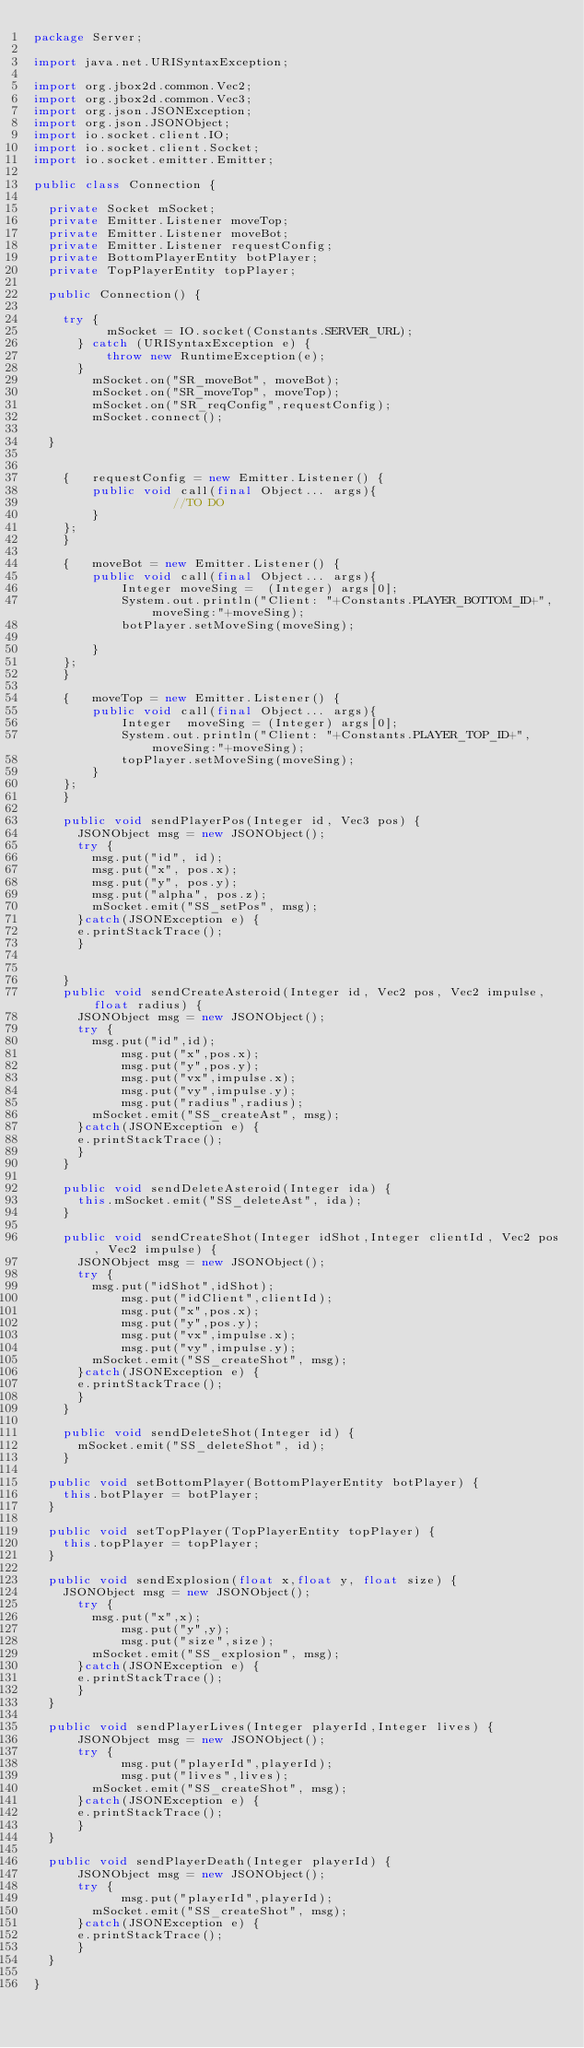<code> <loc_0><loc_0><loc_500><loc_500><_Java_>package Server;

import java.net.URISyntaxException;

import org.jbox2d.common.Vec2;
import org.jbox2d.common.Vec3;
import org.json.JSONException;
import org.json.JSONObject;
import io.socket.client.IO;
import io.socket.client.Socket;
import io.socket.emitter.Emitter;

public class Connection {

	private Socket mSocket;
	private Emitter.Listener moveTop;
	private Emitter.Listener moveBot;
	private Emitter.Listener requestConfig;
	private BottomPlayerEntity botPlayer;
	private TopPlayerEntity topPlayer;
	
	public Connection() {

		try {
	        mSocket = IO.socket(Constants.SERVER_URL);
	    } catch (URISyntaxException e) {
	        throw new RuntimeException(e);
	    }
	      mSocket.on("SR_moveBot", moveBot);
	      mSocket.on("SR_moveTop", moveTop);
	      mSocket.on("SR_reqConfig",requestConfig);
	      mSocket.connect();
		
	}
	
	
    {   requestConfig = new Emitter.Listener() {
        public void call(final Object... args){
                   //TO DO
        }
    };
    }
    
    {   moveBot = new Emitter.Listener() {
        public void call(final Object... args){
            Integer moveSing =  (Integer) args[0];
            System.out.println("Client: "+Constants.PLAYER_BOTTOM_ID+", moveSing:"+moveSing);
            botPlayer.setMoveSing(moveSing);               

        }
    };
    }
    
    {   moveTop = new Emitter.Listener() {
        public void call(final Object... args){
            Integer  moveSing = (Integer) args[0];
            System.out.println("Client: "+Constants.PLAYER_TOP_ID+", moveSing:"+moveSing);
            topPlayer.setMoveSing(moveSing);
        }
    };
    }
    
    public void sendPlayerPos(Integer id, Vec3 pos) {
    	JSONObject msg = new JSONObject();
    	try {
    		msg.put("id", id);
    		msg.put("x", pos.x);
    		msg.put("y", pos.y);
    		msg.put("alpha", pos.z);
    		mSocket.emit("SS_setPos", msg);
    	}catch(JSONException e) {
			e.printStackTrace();
    	}
    	
    	
    }
    public void sendCreateAsteroid(Integer id, Vec2 pos, Vec2 impulse, float radius) {
    	JSONObject msg = new JSONObject();
    	try {
    		msg.put("id",id);
            msg.put("x",pos.x);
            msg.put("y",pos.y);
            msg.put("vx",impulse.x);
            msg.put("vy",impulse.y);
            msg.put("radius",radius);
    		mSocket.emit("SS_createAst", msg);
    	}catch(JSONException e) {
			e.printStackTrace();
    	}
    }
    
    public void sendDeleteAsteroid(Integer ida) {
    	this.mSocket.emit("SS_deleteAst", ida);
    }
    
    public void sendCreateShot(Integer idShot,Integer clientId, Vec2 pos, Vec2 impulse) {
    	JSONObject msg = new JSONObject();
    	try {
    		msg.put("idShot",idShot);
            msg.put("idClient",clientId);
            msg.put("x",pos.x);
            msg.put("y",pos.y);
            msg.put("vx",impulse.x);
            msg.put("vy",impulse.y);
    		mSocket.emit("SS_createShot", msg);
    	}catch(JSONException e) {
			e.printStackTrace();
    	}
    }
    
    public void sendDeleteShot(Integer id) {
    	mSocket.emit("SS_deleteShot", id);
    }

	public void setBottomPlayer(BottomPlayerEntity botPlayer) {
		this.botPlayer = botPlayer;
	}

	public void setTopPlayer(TopPlayerEntity topPlayer) {
		this.topPlayer = topPlayer;
	}
  
	public void sendExplosion(float x,float y, float size) {
		JSONObject msg = new JSONObject();
    	try {
    		msg.put("x",x);
            msg.put("y",y);
            msg.put("size",size);
    		mSocket.emit("SS_explosion", msg);
    	}catch(JSONException e) {
			e.printStackTrace();
    	}
	}
	
	public void sendPlayerLives(Integer playerId,Integer lives) {
    	JSONObject msg = new JSONObject();
    	try {
            msg.put("playerId",playerId);
            msg.put("lives",lives);
    		mSocket.emit("SS_createShot", msg);
    	}catch(JSONException e) {
			e.printStackTrace();
    	}
	}
	
	public void sendPlayerDeath(Integer playerId) {
    	JSONObject msg = new JSONObject();
    	try {
            msg.put("playerId",playerId);
    		mSocket.emit("SS_createShot", msg);
    	}catch(JSONException e) {
			e.printStackTrace();
    	}
	}
    
}
</code> 